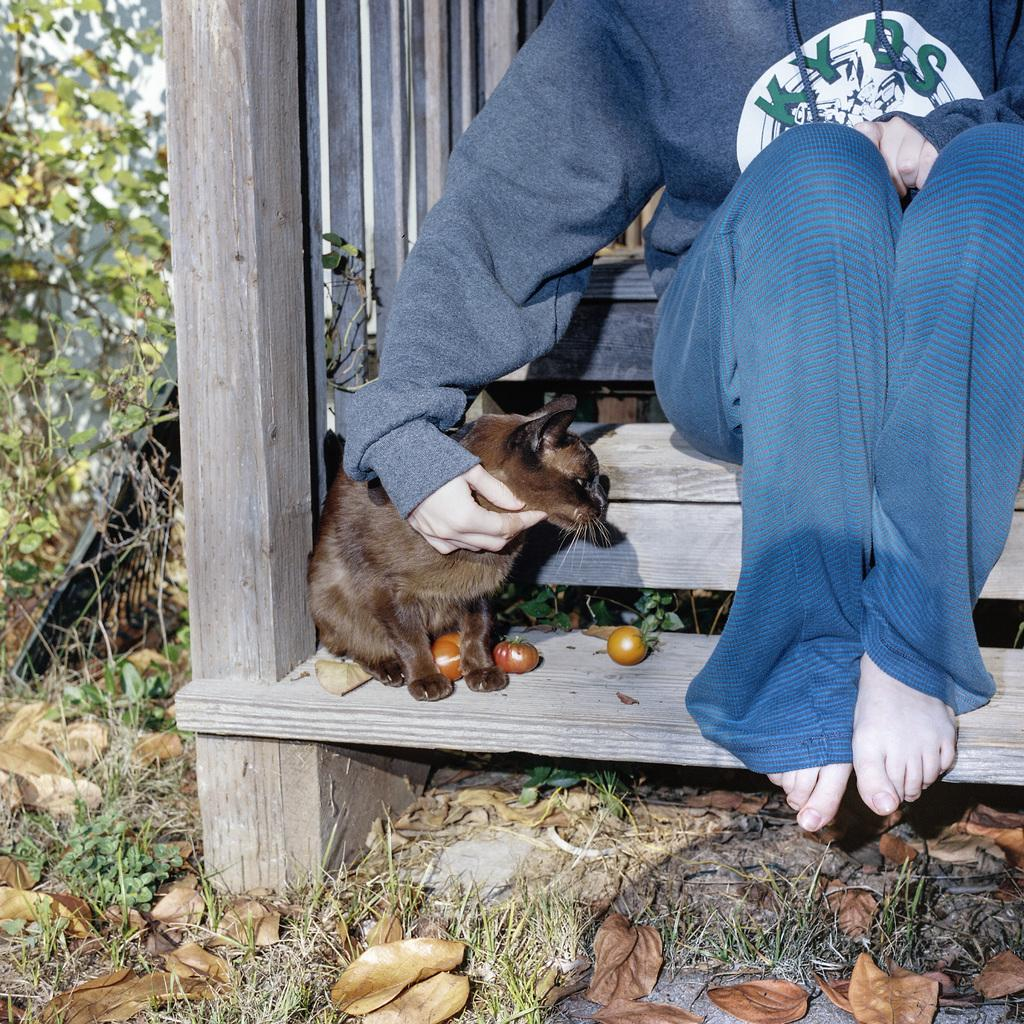What is located in the foreground of the image? There is a cat, tomatoes, and a person sitting on a staircase in the foreground of the image. What type of vegetation can be seen in the background of the image? There is grass and creepers in the background of the image. What architectural feature is visible in the background of the image? There is a wall in the background of the image. Can you describe the time of day when the image might have been taken? The image might have been taken during the day, as there is sufficient light to see the details. What is the name of the person sitting on the staircase in the image? The provided facts do not mention the name of the person sitting on the staircase, so it cannot be determined from the image. Is the image printed or digital? The provided facts do not mention whether the image is printed or digital, so it cannot be determined from the image. 